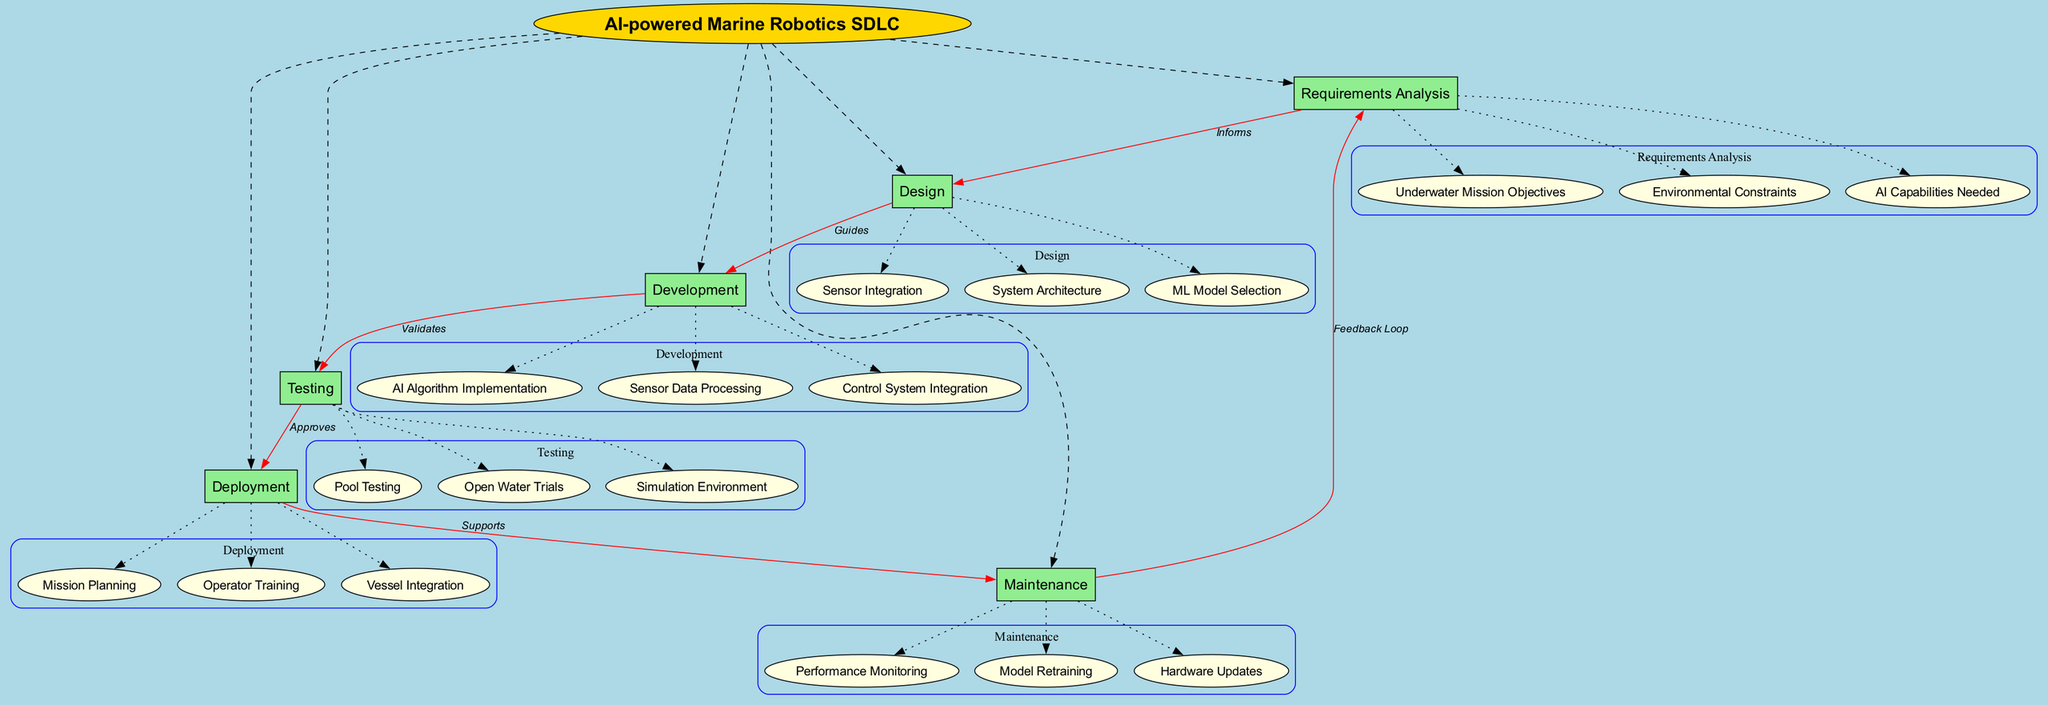What is the central concept of the diagram? The central concept is clearly labeled at the top of the diagram and indicates the overall theme or focus area of the concept map. By identifying the label above the main nodes, we can confirm it is "AI-powered Marine Robotics SDLC".
Answer: AI-powered Marine Robotics SDLC How many main nodes are there in the concept map? We can count the main nodes connected to the central concept, which are the first-level elements of the diagram. There are six main nodes: Requirements Analysis, Design, Development, Testing, Deployment, and Maintenance.
Answer: 6 What is the relationship between Requirements Analysis and Design? The connection between Requirements Analysis and Design is indicated by an edge that specifies the nature of their relationship. The label on this edge reads "Informs", which suggests that Requirements Analysis provides necessary information for the Design phase.
Answer: Informs Which sub-node is associated with Development? By examining the Development node, we can see its connected sub-nodes. The sub-nodes are clearly listed, and one of them is "Control System Integration", which is associated with the Development phase.
Answer: Control System Integration What does Testing approve before Deployment? The Testing node is connected to the Deployment node with a labeled edge. The label on this edge reads "Approves", indicating that the Testing phase needs to validate or approve something before the Deployment can take place. The context suggests it is related to the overall AI-powered marine robotics functionalities.
Answer: Approves What feedback loop exists in the lifecycle? The diagram shows a connection from Maintenance back to Requirements Analysis, labeled "Feedback Loop". This indicates that the results and experiences gathered during the Maintenance phase inform the Requirements Analysis, fostering iterative improvement.
Answer: Feedback Loop How does Development relate to Testing? The relationship between Development and Testing is indicated by an edge that specifies its function. The label on this edge reads "Validates", demonstrating that the Development process creates elements that are validated during the Testing phase.
Answer: Validates What guides the Development phase in the SDLC? The Design node is connected to the Development node, and the edge between them is labeled "Guides". This indicates that the Design phase provides direction and framework for the Development phase in the software development lifecycle.
Answer: Guides List a sub-node related to the Deployment phase. By reviewing the Deployment node, we notice several sub-nodes that are associated with it. One sub-node clearly listed under Deployment is "Mission Planning".
Answer: Mission Planning 